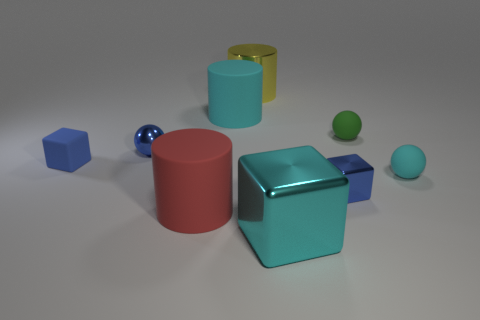Subtract all cyan spheres. How many spheres are left? 2 Subtract all gray balls. How many blue blocks are left? 2 Subtract 1 spheres. How many spheres are left? 2 Subtract all cylinders. How many objects are left? 6 Add 8 cyan rubber cylinders. How many cyan rubber cylinders exist? 9 Subtract 1 cyan cylinders. How many objects are left? 8 Subtract all green blocks. Subtract all purple cylinders. How many blocks are left? 3 Subtract all tiny gray objects. Subtract all red matte objects. How many objects are left? 8 Add 4 small blue shiny balls. How many small blue shiny balls are left? 5 